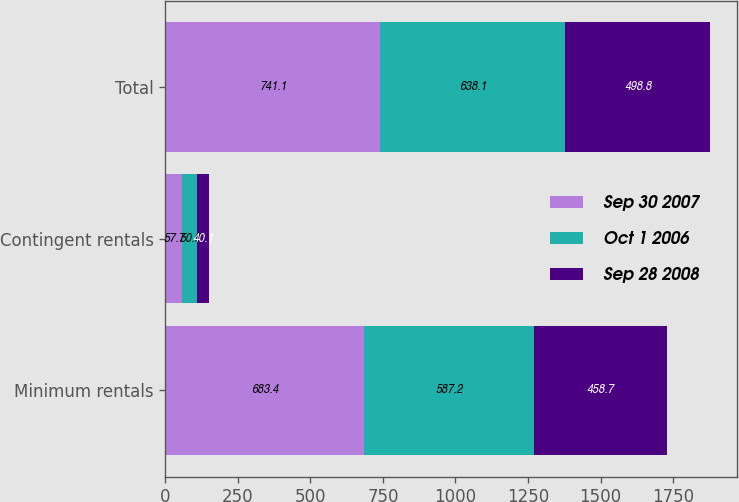Convert chart. <chart><loc_0><loc_0><loc_500><loc_500><stacked_bar_chart><ecel><fcel>Minimum rentals<fcel>Contingent rentals<fcel>Total<nl><fcel>Sep 30 2007<fcel>683.4<fcel>57.7<fcel>741.1<nl><fcel>Oct 1 2006<fcel>587.2<fcel>50.9<fcel>638.1<nl><fcel>Sep 28 2008<fcel>458.7<fcel>40.1<fcel>498.8<nl></chart> 